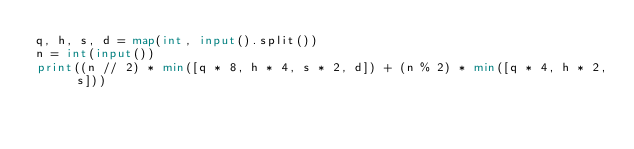<code> <loc_0><loc_0><loc_500><loc_500><_Python_>q, h, s, d = map(int, input().split())
n = int(input())
print((n // 2) * min([q * 8, h * 4, s * 2, d]) + (n % 2) * min([q * 4, h * 2, s]))</code> 